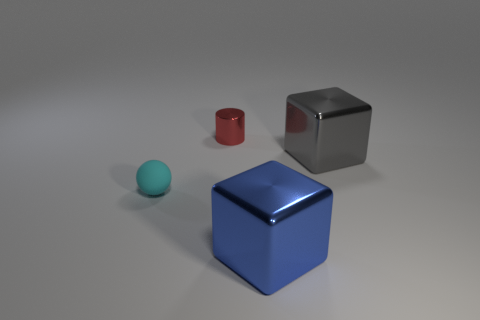What number of objects are tiny purple blocks or small things?
Ensure brevity in your answer.  2. Is the number of blue metal objects behind the small cyan matte ball the same as the number of small spheres?
Your response must be concise. No. There is a cyan rubber sphere that is in front of the block behind the small cyan sphere; is there a cyan thing that is left of it?
Keep it short and to the point. No. The other large thing that is made of the same material as the blue thing is what color?
Provide a short and direct response. Gray. What number of cylinders are tiny cyan matte objects or blue things?
Provide a short and direct response. 0. There is a cube on the right side of the big object left of the big thing that is behind the blue cube; how big is it?
Your answer should be very brief. Large. What shape is the red object that is the same size as the cyan matte sphere?
Your answer should be very brief. Cylinder. There is a large gray metal thing; what shape is it?
Keep it short and to the point. Cube. Are the tiny thing right of the tiny ball and the gray cube made of the same material?
Provide a short and direct response. Yes. What is the size of the block behind the tiny object that is left of the small red shiny cylinder?
Keep it short and to the point. Large. 